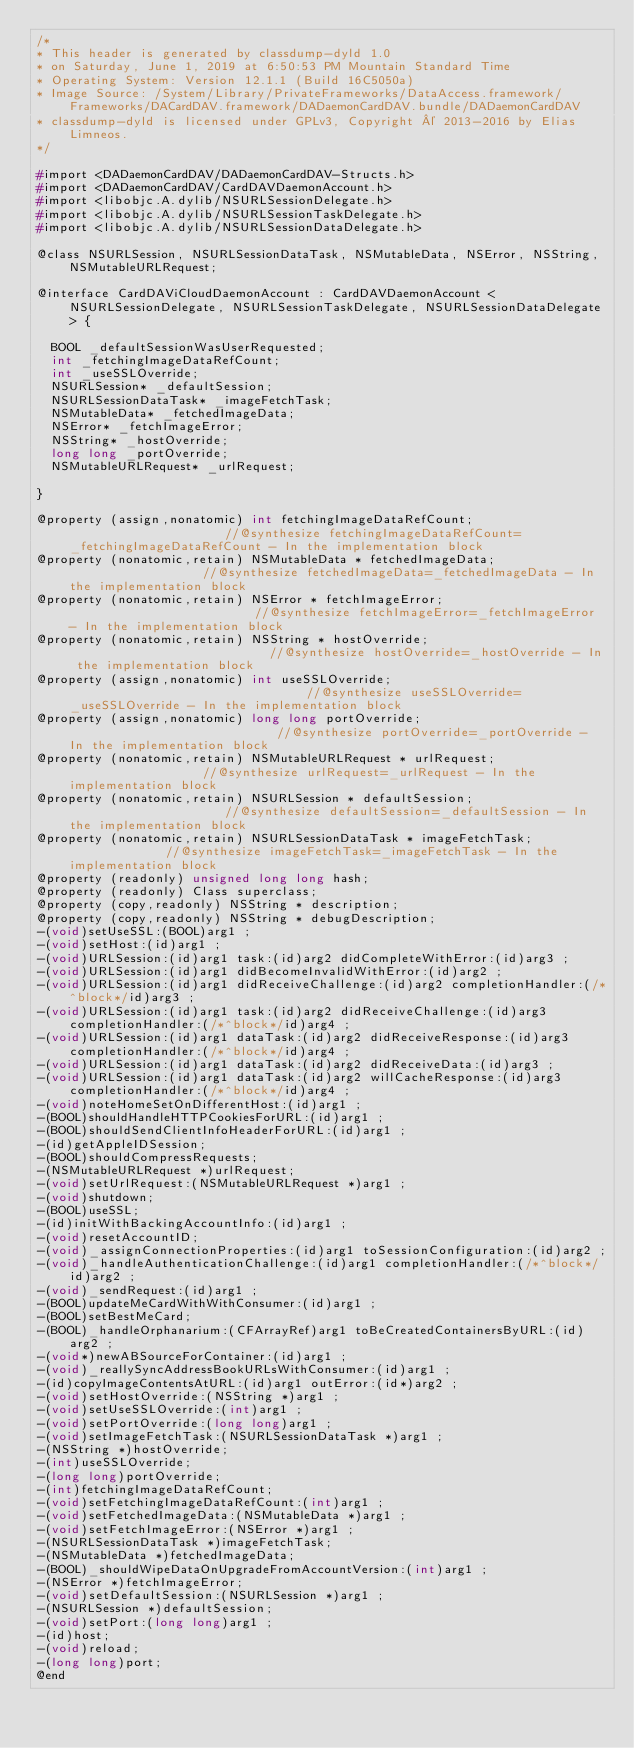Convert code to text. <code><loc_0><loc_0><loc_500><loc_500><_C_>/*
* This header is generated by classdump-dyld 1.0
* on Saturday, June 1, 2019 at 6:50:53 PM Mountain Standard Time
* Operating System: Version 12.1.1 (Build 16C5050a)
* Image Source: /System/Library/PrivateFrameworks/DataAccess.framework/Frameworks/DACardDAV.framework/DADaemonCardDAV.bundle/DADaemonCardDAV
* classdump-dyld is licensed under GPLv3, Copyright © 2013-2016 by Elias Limneos.
*/

#import <DADaemonCardDAV/DADaemonCardDAV-Structs.h>
#import <DADaemonCardDAV/CardDAVDaemonAccount.h>
#import <libobjc.A.dylib/NSURLSessionDelegate.h>
#import <libobjc.A.dylib/NSURLSessionTaskDelegate.h>
#import <libobjc.A.dylib/NSURLSessionDataDelegate.h>

@class NSURLSession, NSURLSessionDataTask, NSMutableData, NSError, NSString, NSMutableURLRequest;

@interface CardDAViCloudDaemonAccount : CardDAVDaemonAccount <NSURLSessionDelegate, NSURLSessionTaskDelegate, NSURLSessionDataDelegate> {

	BOOL _defaultSessionWasUserRequested;
	int _fetchingImageDataRefCount;
	int _useSSLOverride;
	NSURLSession* _defaultSession;
	NSURLSessionDataTask* _imageFetchTask;
	NSMutableData* _fetchedImageData;
	NSError* _fetchImageError;
	NSString* _hostOverride;
	long long _portOverride;
	NSMutableURLRequest* _urlRequest;

}

@property (assign,nonatomic) int fetchingImageDataRefCount;                      //@synthesize fetchingImageDataRefCount=_fetchingImageDataRefCount - In the implementation block
@property (nonatomic,retain) NSMutableData * fetchedImageData;                   //@synthesize fetchedImageData=_fetchedImageData - In the implementation block
@property (nonatomic,retain) NSError * fetchImageError;                          //@synthesize fetchImageError=_fetchImageError - In the implementation block
@property (nonatomic,retain) NSString * hostOverride;                            //@synthesize hostOverride=_hostOverride - In the implementation block
@property (assign,nonatomic) int useSSLOverride;                                 //@synthesize useSSLOverride=_useSSLOverride - In the implementation block
@property (assign,nonatomic) long long portOverride;                             //@synthesize portOverride=_portOverride - In the implementation block
@property (nonatomic,retain) NSMutableURLRequest * urlRequest;                   //@synthesize urlRequest=_urlRequest - In the implementation block
@property (nonatomic,retain) NSURLSession * defaultSession;                      //@synthesize defaultSession=_defaultSession - In the implementation block
@property (nonatomic,retain) NSURLSessionDataTask * imageFetchTask;              //@synthesize imageFetchTask=_imageFetchTask - In the implementation block
@property (readonly) unsigned long long hash; 
@property (readonly) Class superclass; 
@property (copy,readonly) NSString * description; 
@property (copy,readonly) NSString * debugDescription; 
-(void)setUseSSL:(BOOL)arg1 ;
-(void)setHost:(id)arg1 ;
-(void)URLSession:(id)arg1 task:(id)arg2 didCompleteWithError:(id)arg3 ;
-(void)URLSession:(id)arg1 didBecomeInvalidWithError:(id)arg2 ;
-(void)URLSession:(id)arg1 didReceiveChallenge:(id)arg2 completionHandler:(/*^block*/id)arg3 ;
-(void)URLSession:(id)arg1 task:(id)arg2 didReceiveChallenge:(id)arg3 completionHandler:(/*^block*/id)arg4 ;
-(void)URLSession:(id)arg1 dataTask:(id)arg2 didReceiveResponse:(id)arg3 completionHandler:(/*^block*/id)arg4 ;
-(void)URLSession:(id)arg1 dataTask:(id)arg2 didReceiveData:(id)arg3 ;
-(void)URLSession:(id)arg1 dataTask:(id)arg2 willCacheResponse:(id)arg3 completionHandler:(/*^block*/id)arg4 ;
-(void)noteHomeSetOnDifferentHost:(id)arg1 ;
-(BOOL)shouldHandleHTTPCookiesForURL:(id)arg1 ;
-(BOOL)shouldSendClientInfoHeaderForURL:(id)arg1 ;
-(id)getAppleIDSession;
-(BOOL)shouldCompressRequests;
-(NSMutableURLRequest *)urlRequest;
-(void)setUrlRequest:(NSMutableURLRequest *)arg1 ;
-(void)shutdown;
-(BOOL)useSSL;
-(id)initWithBackingAccountInfo:(id)arg1 ;
-(void)resetAccountID;
-(void)_assignConnectionProperties:(id)arg1 toSessionConfiguration:(id)arg2 ;
-(void)_handleAuthenticationChallenge:(id)arg1 completionHandler:(/*^block*/id)arg2 ;
-(void)_sendRequest:(id)arg1 ;
-(BOOL)updateMeCardWithWithConsumer:(id)arg1 ;
-(BOOL)setBestMeCard;
-(BOOL)_handleOrphanarium:(CFArrayRef)arg1 toBeCreatedContainersByURL:(id)arg2 ;
-(void*)newABSourceForContainer:(id)arg1 ;
-(void)_reallySyncAddressBookURLsWithConsumer:(id)arg1 ;
-(id)copyImageContentsAtURL:(id)arg1 outError:(id*)arg2 ;
-(void)setHostOverride:(NSString *)arg1 ;
-(void)setUseSSLOverride:(int)arg1 ;
-(void)setPortOverride:(long long)arg1 ;
-(void)setImageFetchTask:(NSURLSessionDataTask *)arg1 ;
-(NSString *)hostOverride;
-(int)useSSLOverride;
-(long long)portOverride;
-(int)fetchingImageDataRefCount;
-(void)setFetchingImageDataRefCount:(int)arg1 ;
-(void)setFetchedImageData:(NSMutableData *)arg1 ;
-(void)setFetchImageError:(NSError *)arg1 ;
-(NSURLSessionDataTask *)imageFetchTask;
-(NSMutableData *)fetchedImageData;
-(BOOL)_shouldWipeDataOnUpgradeFromAccountVersion:(int)arg1 ;
-(NSError *)fetchImageError;
-(void)setDefaultSession:(NSURLSession *)arg1 ;
-(NSURLSession *)defaultSession;
-(void)setPort:(long long)arg1 ;
-(id)host;
-(void)reload;
-(long long)port;
@end

</code> 